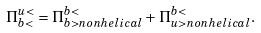Convert formula to latex. <formula><loc_0><loc_0><loc_500><loc_500>\Pi ^ { u < } _ { b < } = \Pi ^ { b < } _ { b > n o n h e l i c a l } + \Pi ^ { b < } _ { u > n o n h e l i c a l } .</formula> 